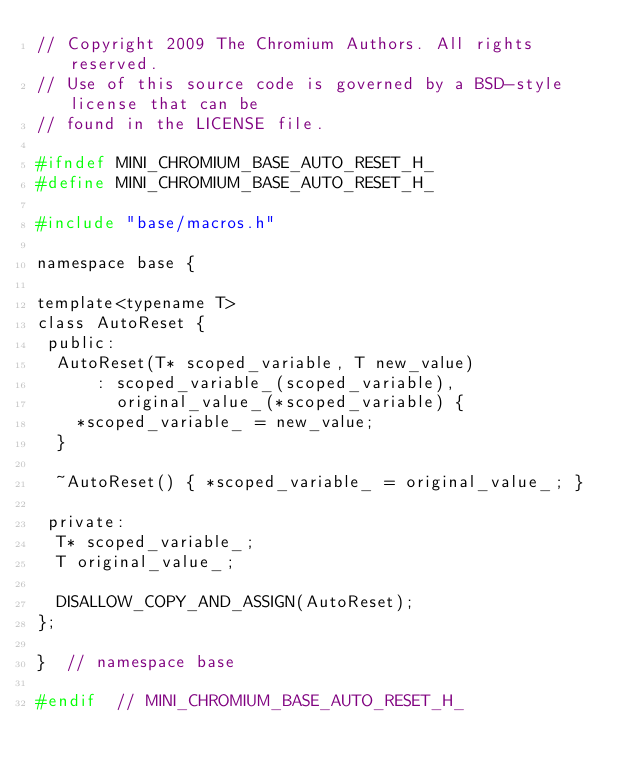<code> <loc_0><loc_0><loc_500><loc_500><_C_>// Copyright 2009 The Chromium Authors. All rights reserved.
// Use of this source code is governed by a BSD-style license that can be
// found in the LICENSE file.

#ifndef MINI_CHROMIUM_BASE_AUTO_RESET_H_
#define MINI_CHROMIUM_BASE_AUTO_RESET_H_

#include "base/macros.h"

namespace base {

template<typename T>
class AutoReset {
 public:
  AutoReset(T* scoped_variable, T new_value)
      : scoped_variable_(scoped_variable),
        original_value_(*scoped_variable) {
    *scoped_variable_ = new_value;
  }

  ~AutoReset() { *scoped_variable_ = original_value_; }

 private:
  T* scoped_variable_;
  T original_value_;

  DISALLOW_COPY_AND_ASSIGN(AutoReset);
};

}  // namespace base

#endif  // MINI_CHROMIUM_BASE_AUTO_RESET_H_
</code> 